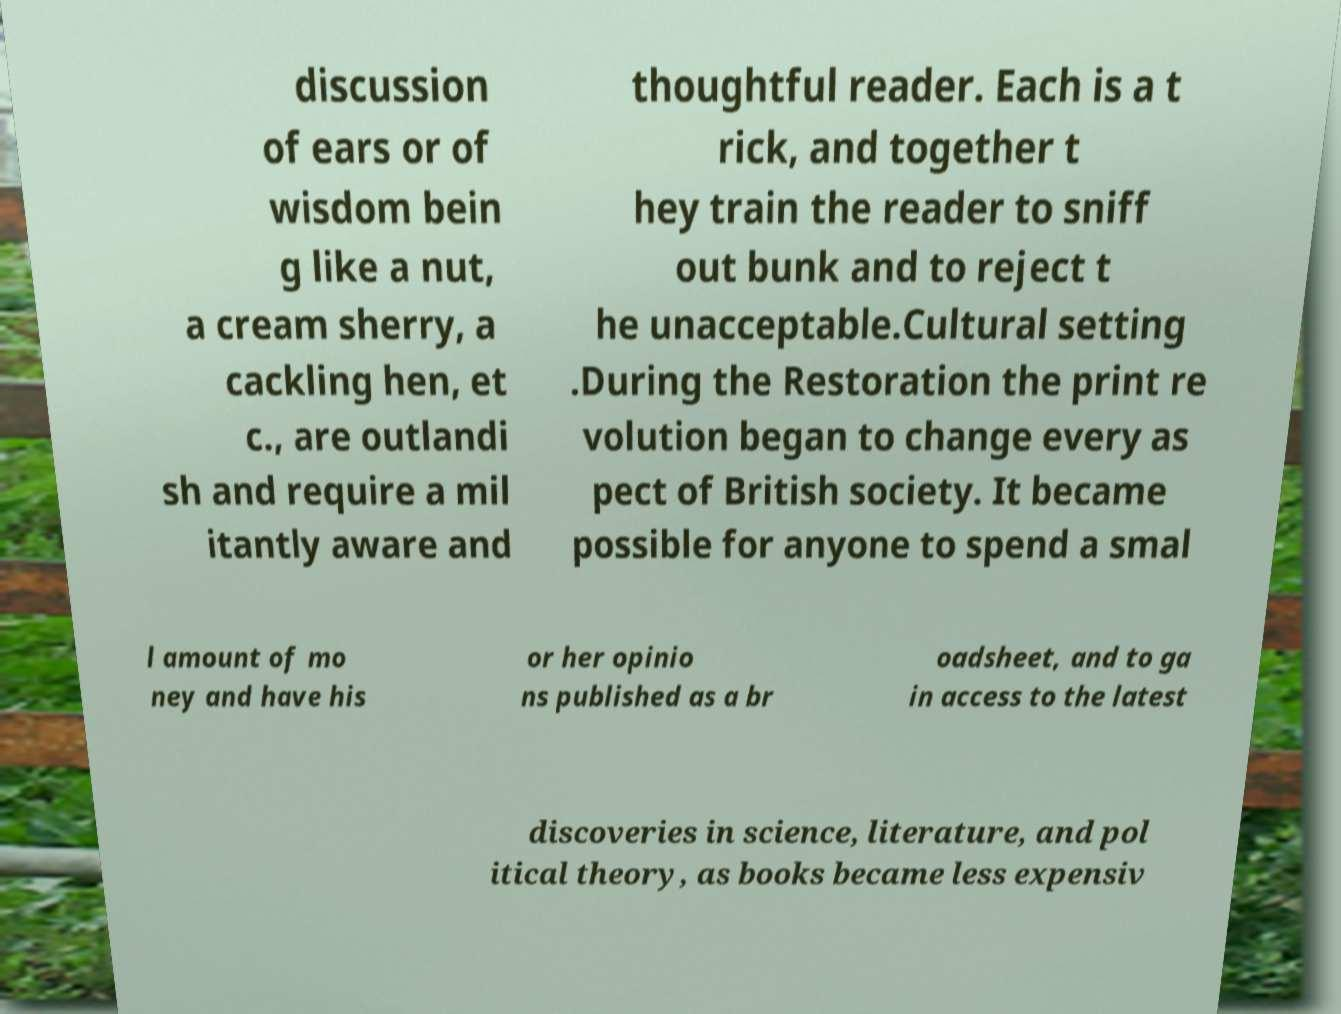Please read and relay the text visible in this image. What does it say? discussion of ears or of wisdom bein g like a nut, a cream sherry, a cackling hen, et c., are outlandi sh and require a mil itantly aware and thoughtful reader. Each is a t rick, and together t hey train the reader to sniff out bunk and to reject t he unacceptable.Cultural setting .During the Restoration the print re volution began to change every as pect of British society. It became possible for anyone to spend a smal l amount of mo ney and have his or her opinio ns published as a br oadsheet, and to ga in access to the latest discoveries in science, literature, and pol itical theory, as books became less expensiv 